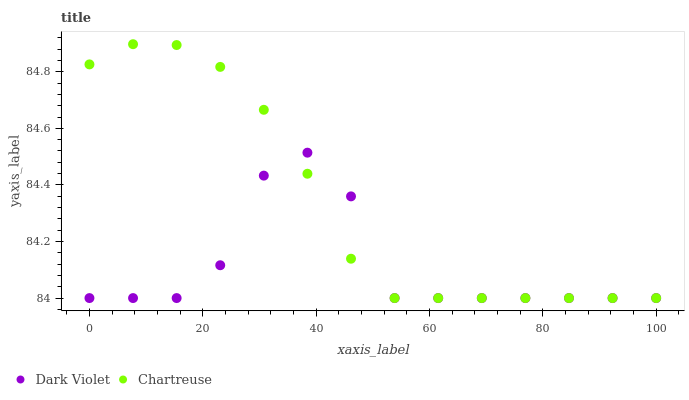Does Dark Violet have the minimum area under the curve?
Answer yes or no. Yes. Does Chartreuse have the maximum area under the curve?
Answer yes or no. Yes. Does Dark Violet have the maximum area under the curve?
Answer yes or no. No. Is Chartreuse the smoothest?
Answer yes or no. Yes. Is Dark Violet the roughest?
Answer yes or no. Yes. Is Dark Violet the smoothest?
Answer yes or no. No. Does Chartreuse have the lowest value?
Answer yes or no. Yes. Does Chartreuse have the highest value?
Answer yes or no. Yes. Does Dark Violet have the highest value?
Answer yes or no. No. Does Chartreuse intersect Dark Violet?
Answer yes or no. Yes. Is Chartreuse less than Dark Violet?
Answer yes or no. No. Is Chartreuse greater than Dark Violet?
Answer yes or no. No. 